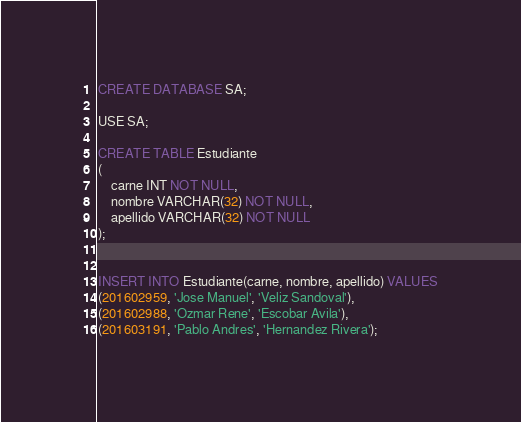<code> <loc_0><loc_0><loc_500><loc_500><_SQL_>CREATE DATABASE SA;

USE SA;

CREATE TABLE Estudiante
(
    carne INT NOT NULL,
    nombre VARCHAR(32) NOT NULL,
    apellido VARCHAR(32) NOT NULL
);


INSERT INTO Estudiante(carne, nombre, apellido) VALUES
(201602959, 'Jose Manuel', 'Veliz Sandoval'),
(201602988, 'Ozmar Rene', 'Escobar Avila'),
(201603191, 'Pablo Andres', 'Hernandez Rivera');</code> 